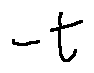Convert formula to latex. <formula><loc_0><loc_0><loc_500><loc_500>- t</formula> 